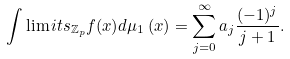<formula> <loc_0><loc_0><loc_500><loc_500>\int \lim i t s _ { \mathbb { Z } _ { p } } f ( x ) d \mu _ { 1 } \left ( x \right ) = \sum _ { j = 0 } ^ { \infty } a _ { j } \frac { ( - 1 ) ^ { j } } { j + 1 } .</formula> 